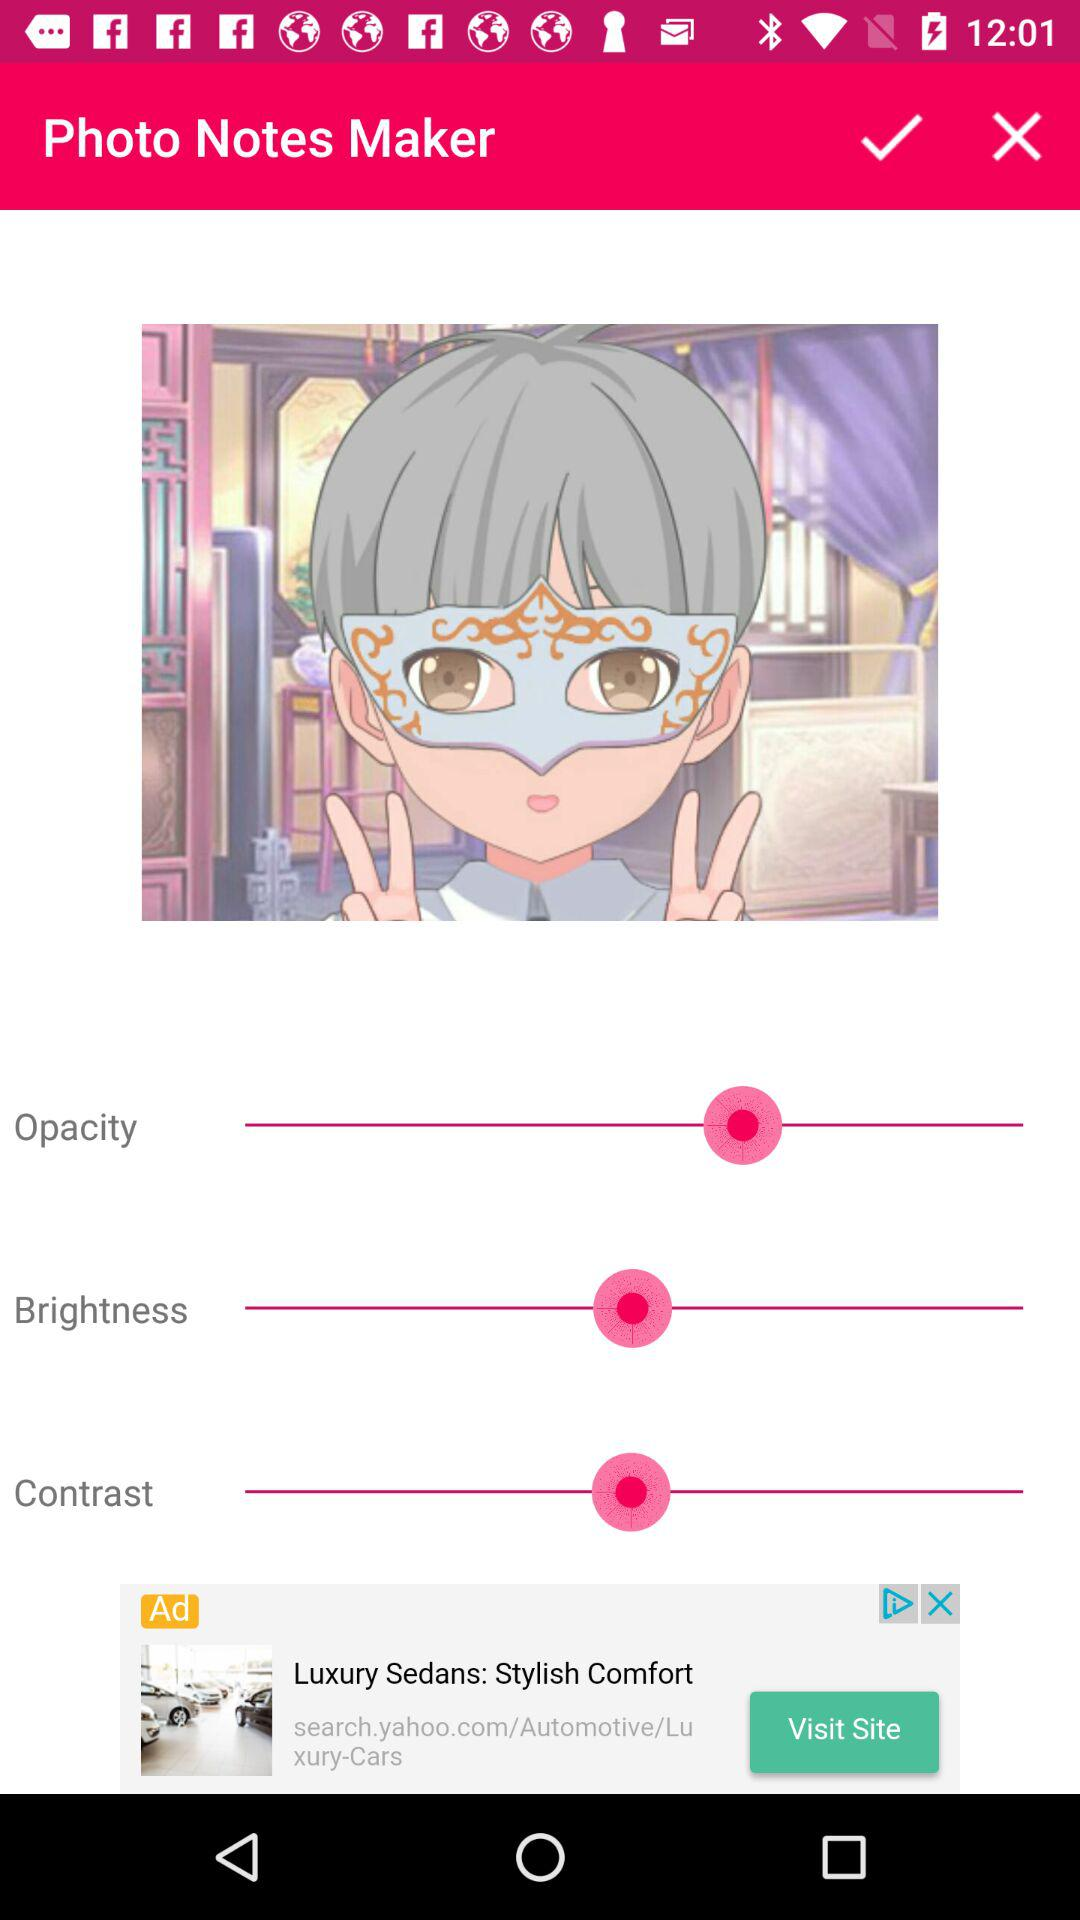What is the application name? The application name is "Photo Notes Maker". 